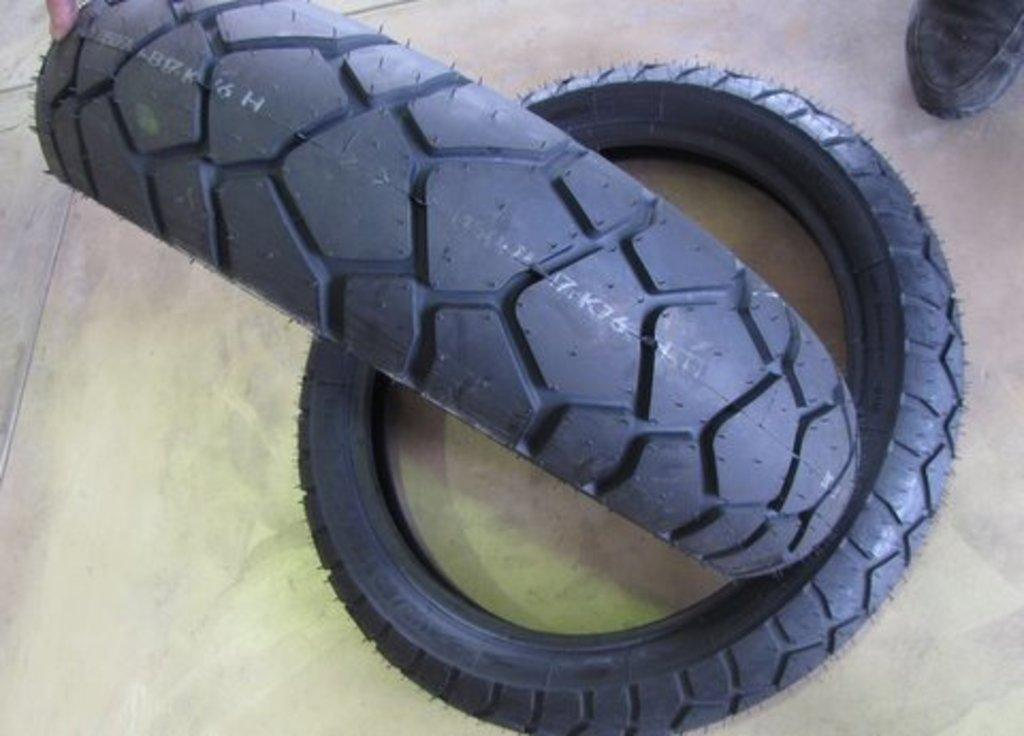What objects are present in the image that are related to vehicles? There are tyres in the image. What type of footwear can be seen in the image? There are black color shoes in the image. What advice does the friend give during the meeting in the image? There is no friend or meeting present in the image; it only features tyres and black shoes. How does the brain function in the image? There is no brain present in the image, so it is not possible to determine how it functions. 